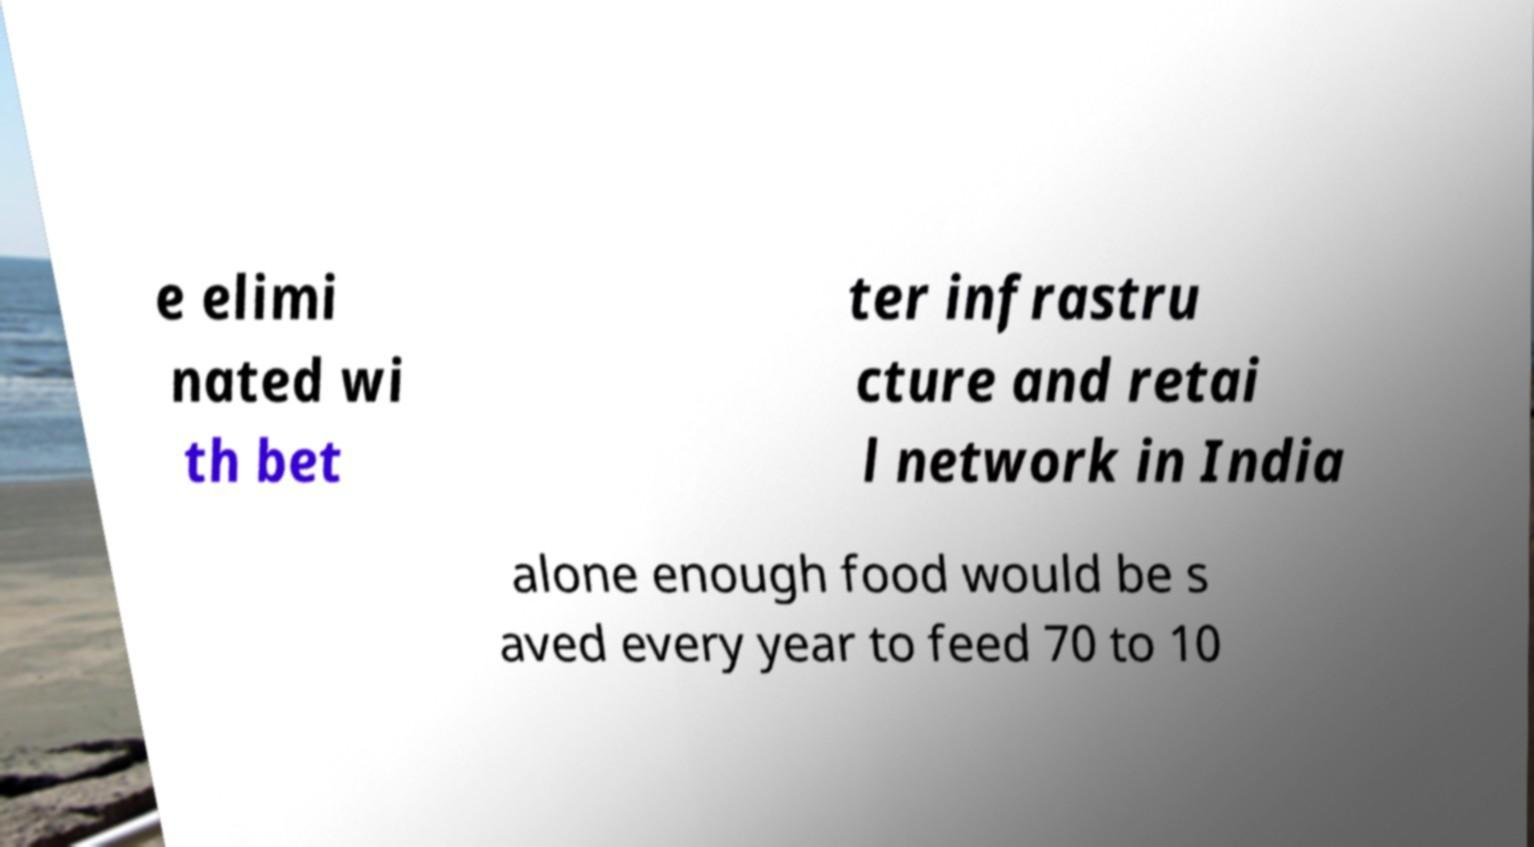I need the written content from this picture converted into text. Can you do that? e elimi nated wi th bet ter infrastru cture and retai l network in India alone enough food would be s aved every year to feed 70 to 10 